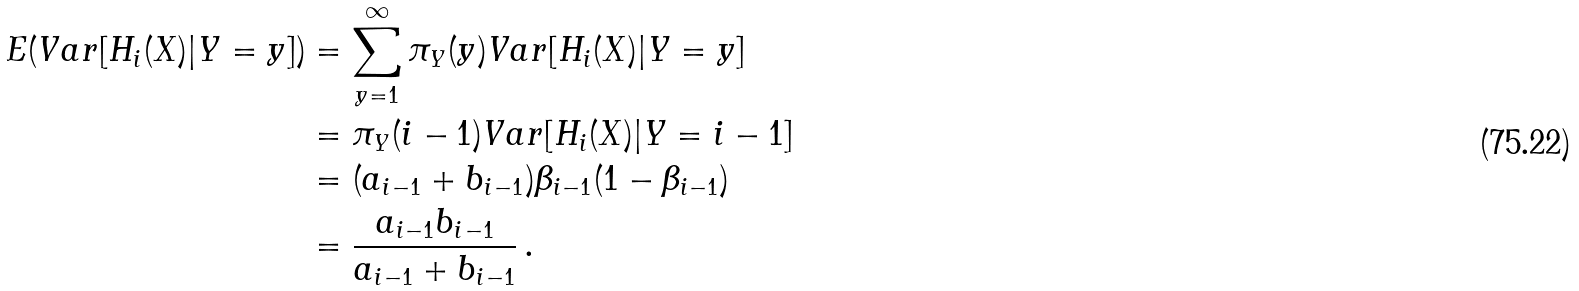Convert formula to latex. <formula><loc_0><loc_0><loc_500><loc_500>E ( V a r [ H _ { i } ( X ) | Y = y ] ) & = \sum _ { y = 1 } ^ { \infty } \pi _ { Y } ( y ) V a r [ H _ { i } ( X ) | Y = y ] \\ & = \pi _ { Y } ( i - 1 ) V a r [ H _ { i } ( X ) | Y = i - 1 ] \\ & = ( a _ { i - 1 } + b _ { i - 1 } ) \beta _ { i - 1 } ( 1 - \beta _ { i - 1 } ) \\ & = \frac { a _ { i - 1 } b _ { i - 1 } } { a _ { i - 1 } + b _ { i - 1 } } \, .</formula> 